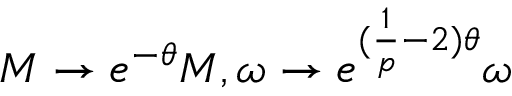<formula> <loc_0><loc_0><loc_500><loc_500>M \rightarrow e ^ { - \theta } M , \omega \rightarrow e ^ { ( \frac { 1 } { p } - 2 ) \theta } \omega</formula> 